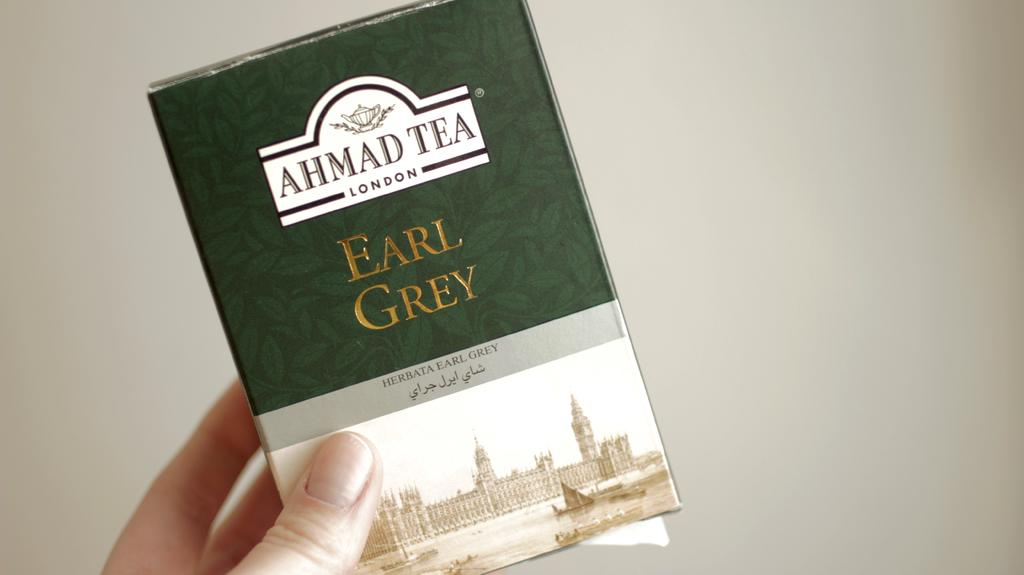<image>
Describe the image concisely. A hand is holding a bax of Earl Grey from Ahmad Tea. 